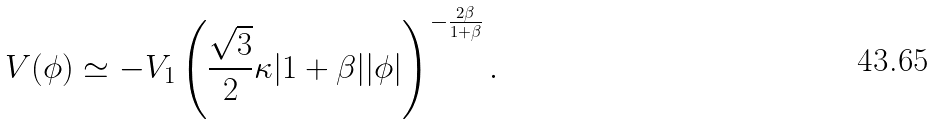Convert formula to latex. <formula><loc_0><loc_0><loc_500><loc_500>V ( \phi ) \simeq - V _ { 1 } \left ( \frac { \sqrt { 3 } } { 2 } \kappa | 1 + \beta | | \phi | \right ) ^ { - \frac { 2 \beta } { 1 + \beta } } .</formula> 